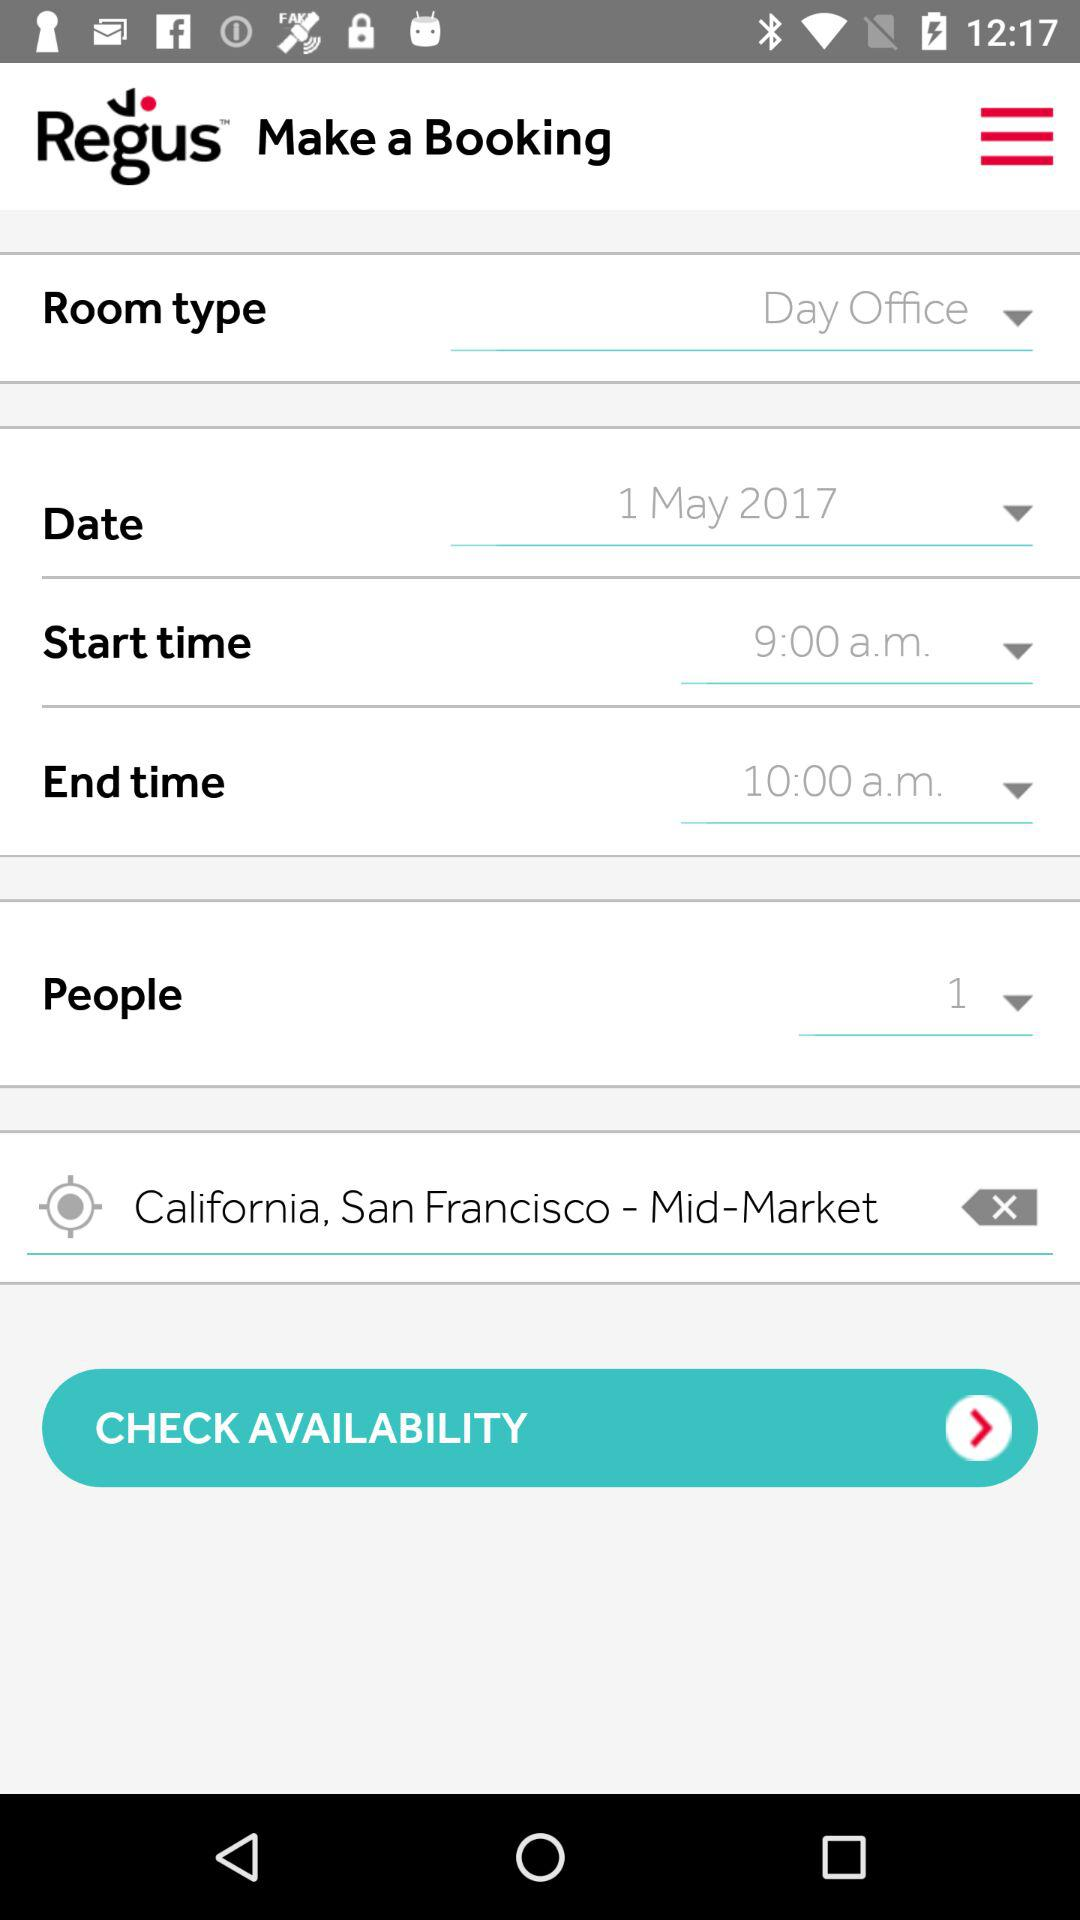What is the application name? The application name is "Regus". 